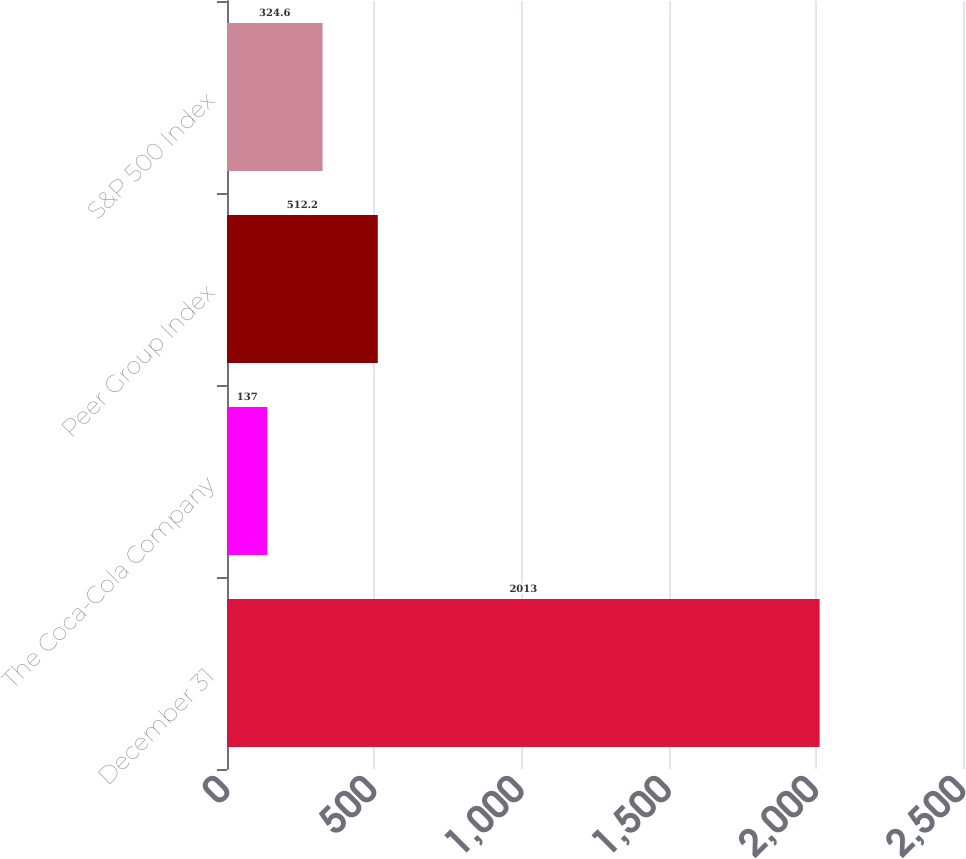Convert chart. <chart><loc_0><loc_0><loc_500><loc_500><bar_chart><fcel>December 31<fcel>The Coca-Cola Company<fcel>Peer Group Index<fcel>S&P 500 Index<nl><fcel>2013<fcel>137<fcel>512.2<fcel>324.6<nl></chart> 